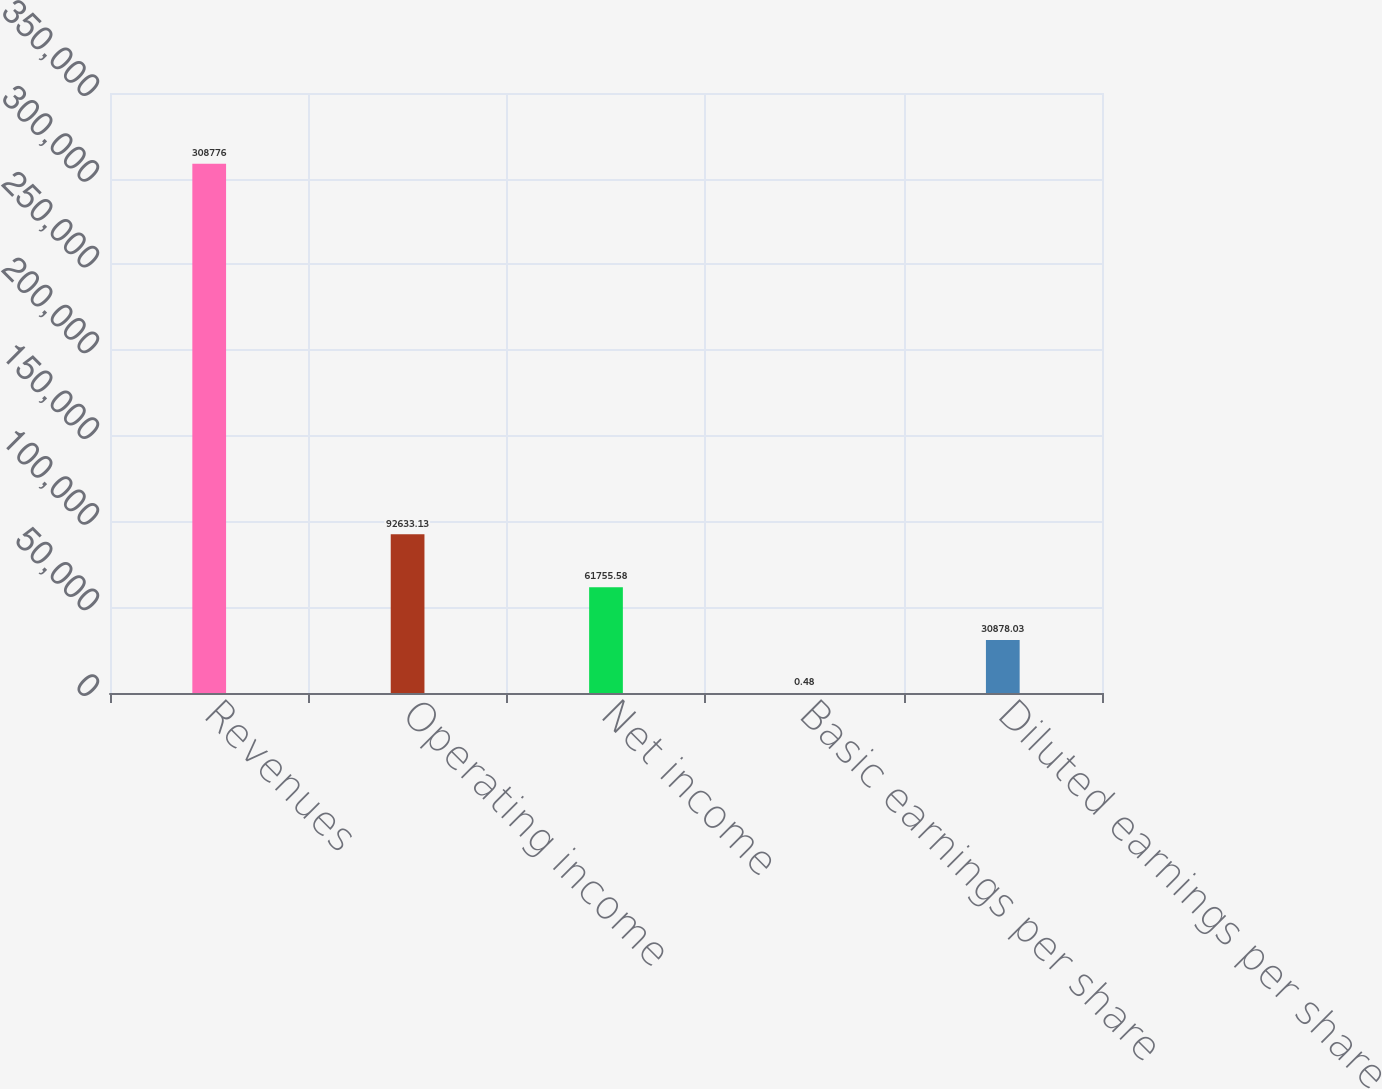<chart> <loc_0><loc_0><loc_500><loc_500><bar_chart><fcel>Revenues<fcel>Operating income<fcel>Net income<fcel>Basic earnings per share<fcel>Diluted earnings per share<nl><fcel>308776<fcel>92633.1<fcel>61755.6<fcel>0.48<fcel>30878<nl></chart> 